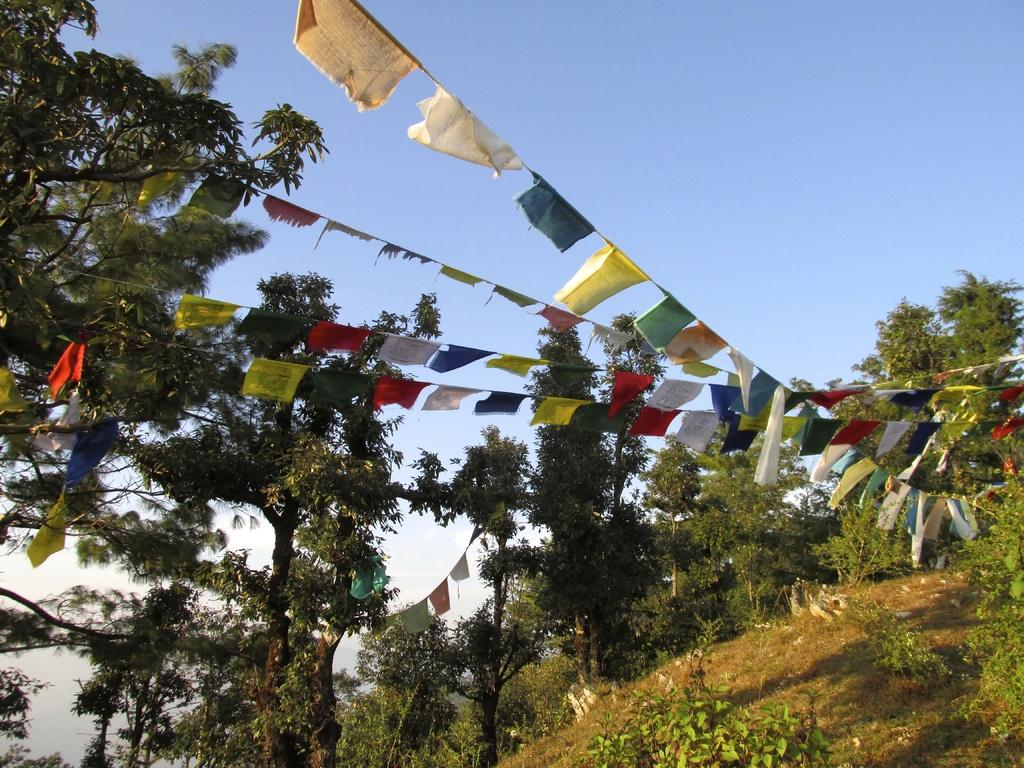What type of vegetation is present in the image? There are many trees in the image. What is visible at the bottom of the image? Grass is visible at the bottom of the image. How are the flags positioned in the image? The flags are tied with a rope in the image. What is visible at the top of the image? The sky is visible at the top of the image. Can you see any icicles hanging from the trees in the image? There are no icicles present in the image; it features trees with leaves or needles. 